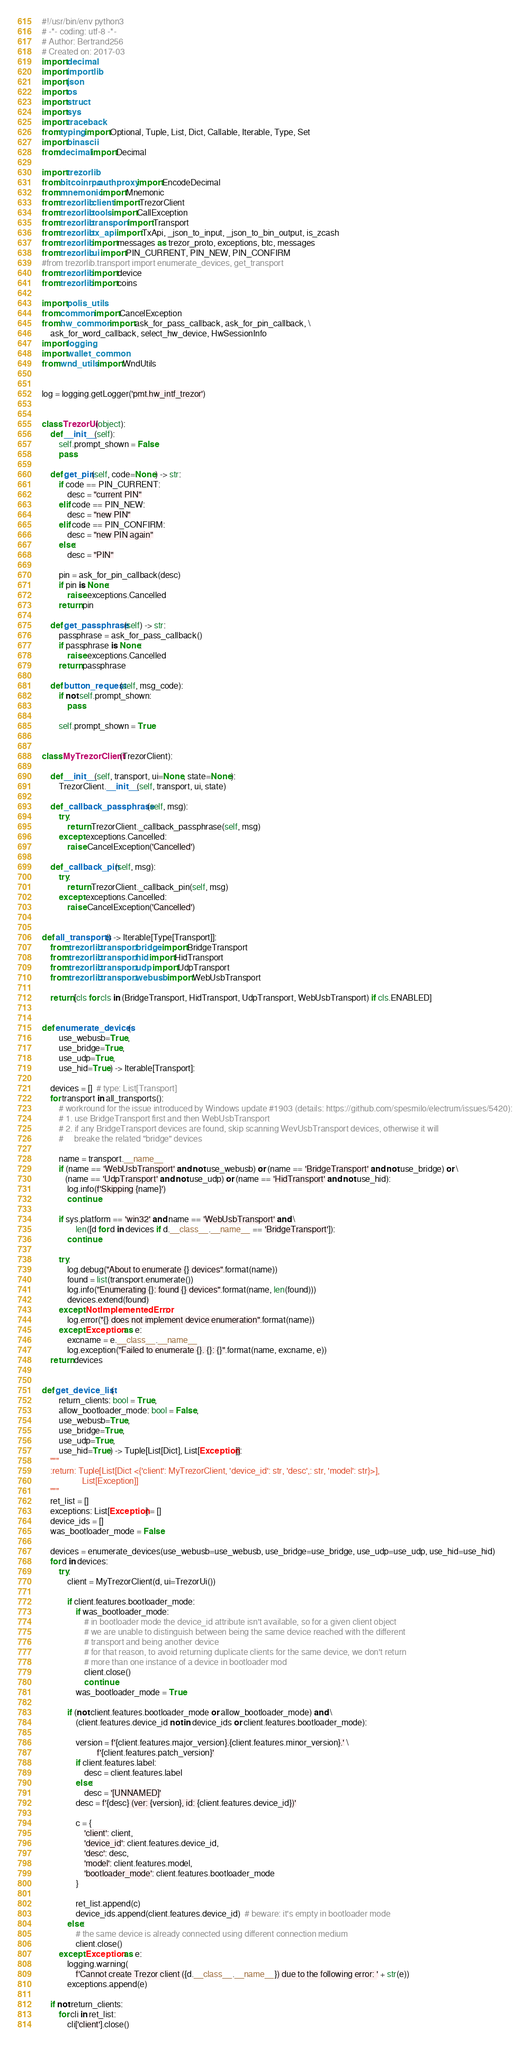Convert code to text. <code><loc_0><loc_0><loc_500><loc_500><_Python_>#!/usr/bin/env python3
# -*- coding: utf-8 -*-
# Author: Bertrand256
# Created on: 2017-03
import decimal
import importlib
import json
import os
import struct
import sys
import traceback
from typing import Optional, Tuple, List, Dict, Callable, Iterable, Type, Set
import binascii
from decimal import Decimal

import trezorlib
from bitcoinrpc.authproxy import EncodeDecimal
from mnemonic import Mnemonic
from trezorlib.client import TrezorClient
from trezorlib.tools import CallException
from trezorlib.transport import Transport
from trezorlib.tx_api import TxApi, _json_to_input, _json_to_bin_output, is_zcash
from trezorlib import messages as trezor_proto, exceptions, btc, messages
from trezorlib.ui import PIN_CURRENT, PIN_NEW, PIN_CONFIRM
#from trezorlib.transport import enumerate_devices, get_transport
from trezorlib import device
from trezorlib import coins

import polis_utils
from common import CancelException
from hw_common import ask_for_pass_callback, ask_for_pin_callback, \
    ask_for_word_callback, select_hw_device, HwSessionInfo
import logging
import wallet_common
from wnd_utils import WndUtils


log = logging.getLogger('pmt.hw_intf_trezor')


class TrezorUi(object):
    def __init__(self):
        self.prompt_shown = False
        pass

    def get_pin(self, code=None) -> str:
        if code == PIN_CURRENT:
            desc = "current PIN"
        elif code == PIN_NEW:
            desc = "new PIN"
        elif code == PIN_CONFIRM:
            desc = "new PIN again"
        else:
            desc = "PIN"

        pin = ask_for_pin_callback(desc)
        if pin is None:
            raise exceptions.Cancelled
        return pin

    def get_passphrase(self) -> str:
        passphrase = ask_for_pass_callback()
        if passphrase is None:
            raise exceptions.Cancelled
        return passphrase

    def button_request(self, msg_code):
        if not self.prompt_shown:
            pass

        self.prompt_shown = True


class MyTrezorClient(TrezorClient):

    def __init__(self, transport, ui=None, state=None):
        TrezorClient.__init__(self, transport, ui, state)

    def _callback_passphrase(self, msg):
        try:
            return TrezorClient._callback_passphrase(self, msg)
        except exceptions.Cancelled:
            raise CancelException('Cancelled')

    def _callback_pin(self, msg):
        try:
            return TrezorClient._callback_pin(self, msg)
        except exceptions.Cancelled:
            raise CancelException('Cancelled')


def all_transports() -> Iterable[Type[Transport]]:
    from trezorlib.transport.bridge import BridgeTransport
    from trezorlib.transport.hid import HidTransport
    from trezorlib.transport.udp import UdpTransport
    from trezorlib.transport.webusb import WebUsbTransport

    return [cls for cls in (BridgeTransport, HidTransport, UdpTransport, WebUsbTransport) if cls.ENABLED]


def enumerate_devices(
        use_webusb=True,
        use_bridge=True,
        use_udp=True,
        use_hid=True) -> Iterable[Transport]:

    devices = []  # type: List[Transport]
    for transport in all_transports():
        # workround for the issue introduced by Windows update #1903 (details: https://github.com/spesmilo/electrum/issues/5420):
        # 1. use BridgeTransport first and then WebUsbTransport
        # 2. if any BridgeTransport devices are found, skip scanning WevUsbTransport devices, otherwise it will
        #     breake the related "bridge" devices

        name = transport.__name__
        if (name == 'WebUsbTransport' and not use_webusb) or (name == 'BridgeTransport' and not use_bridge) or \
           (name == 'UdpTransport' and not use_udp) or (name == 'HidTransport' and not use_hid):
            log.info(f'Skipping {name}')
            continue

        if sys.platform == 'win32' and name == 'WebUsbTransport' and \
                len([d for d in devices if d.__class__.__name__ == 'BridgeTransport']):
            continue

        try:
            log.debug("About to enumerate {} devices".format(name))
            found = list(transport.enumerate())
            log.info("Enumerating {}: found {} devices".format(name, len(found)))
            devices.extend(found)
        except NotImplementedError:
            log.error("{} does not implement device enumeration".format(name))
        except Exception as e:
            excname = e.__class__.__name__
            log.exception("Failed to enumerate {}. {}: {}".format(name, excname, e))
    return devices


def get_device_list(
        return_clients: bool = True,
        allow_bootloader_mode: bool = False,
        use_webusb=True,
        use_bridge=True,
        use_udp=True,
        use_hid=True) -> Tuple[List[Dict], List[Exception]]:
    """
    :return: Tuple[List[Dict <{'client': MyTrezorClient, 'device_id': str, 'desc',: str, 'model': str}>],
                   List[Exception]]
    """
    ret_list = []
    exceptions: List[Exception] = []
    device_ids = []
    was_bootloader_mode = False

    devices = enumerate_devices(use_webusb=use_webusb, use_bridge=use_bridge, use_udp=use_udp, use_hid=use_hid)
    for d in devices:
        try:
            client = MyTrezorClient(d, ui=TrezorUi())

            if client.features.bootloader_mode:
                if was_bootloader_mode:
                    # in bootloader mode the device_id attribute isn't available, so for a given client object
                    # we are unable to distinguish between being the same device reached with the different
                    # transport and being another device
                    # for that reason, to avoid returning duplicate clients for the same device, we don't return
                    # more than one instance of a device in bootloader mod
                    client.close()
                    continue
                was_bootloader_mode = True

            if (not client.features.bootloader_mode or allow_bootloader_mode) and \
                (client.features.device_id not in device_ids or client.features.bootloader_mode):

                version = f'{client.features.major_version}.{client.features.minor_version}.' \
                          f'{client.features.patch_version}'
                if client.features.label:
                    desc = client.features.label
                else:
                    desc = '[UNNAMED]'
                desc = f'{desc} (ver: {version}, id: {client.features.device_id})'

                c = {
                    'client': client,
                    'device_id': client.features.device_id,
                    'desc': desc,
                    'model': client.features.model,
                    'bootloader_mode': client.features.bootloader_mode
                }

                ret_list.append(c)
                device_ids.append(client.features.device_id)  # beware: it's empty in bootloader mode
            else:
                # the same device is already connected using different connection medium
                client.close()
        except Exception as e:
            logging.warning(
                f'Cannot create Trezor client ({d.__class__.__name__}) due to the following error: ' + str(e))
            exceptions.append(e)

    if not return_clients:
        for cli in ret_list:
            cli['client'].close()</code> 